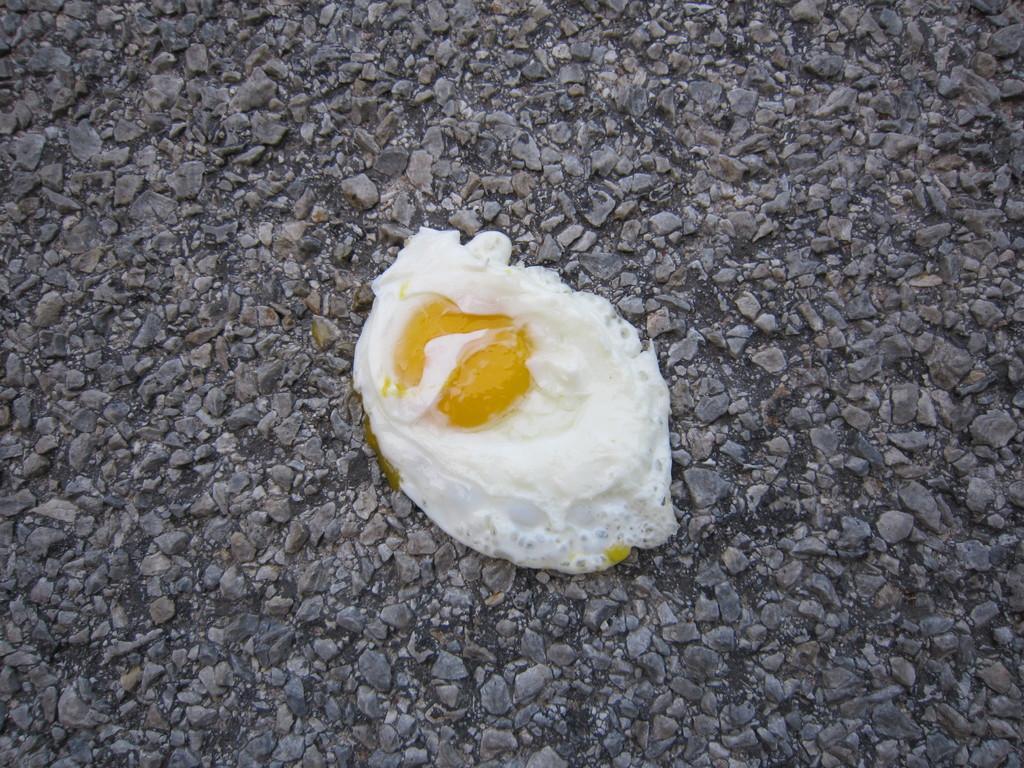Describe this image in one or two sentences. In the image there is a poached egg on stones surface. 